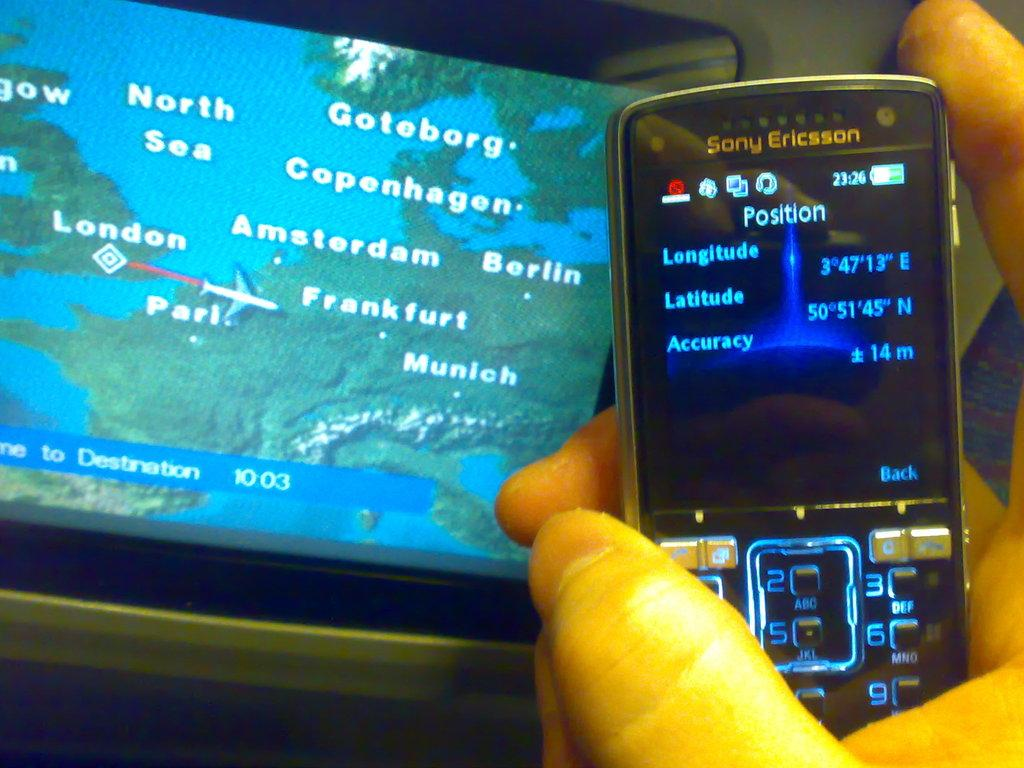<image>
Provide a brief description of the given image. a phone with the word position at the top 